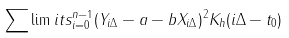<formula> <loc_0><loc_0><loc_500><loc_500>\sum \lim i t s _ { i = 0 } ^ { n - 1 } ( Y _ { i \Delta } - a - b X _ { i \Delta } ) ^ { 2 } K _ { h } ( i \Delta - t _ { 0 } )</formula> 